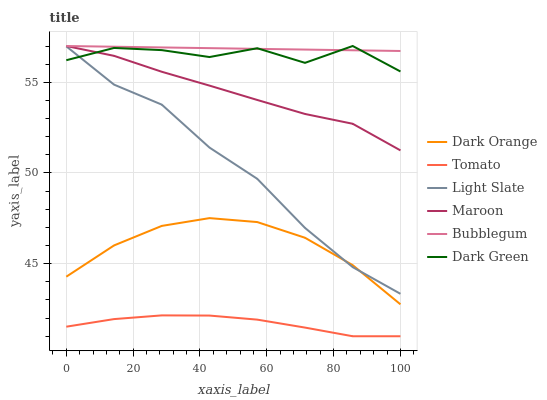Does Tomato have the minimum area under the curve?
Answer yes or no. Yes. Does Bubblegum have the maximum area under the curve?
Answer yes or no. Yes. Does Dark Orange have the minimum area under the curve?
Answer yes or no. No. Does Dark Orange have the maximum area under the curve?
Answer yes or no. No. Is Bubblegum the smoothest?
Answer yes or no. Yes. Is Dark Green the roughest?
Answer yes or no. Yes. Is Dark Orange the smoothest?
Answer yes or no. No. Is Dark Orange the roughest?
Answer yes or no. No. Does Tomato have the lowest value?
Answer yes or no. Yes. Does Dark Orange have the lowest value?
Answer yes or no. No. Does Dark Green have the highest value?
Answer yes or no. Yes. Does Dark Orange have the highest value?
Answer yes or no. No. Is Dark Orange less than Maroon?
Answer yes or no. Yes. Is Bubblegum greater than Tomato?
Answer yes or no. Yes. Does Bubblegum intersect Maroon?
Answer yes or no. Yes. Is Bubblegum less than Maroon?
Answer yes or no. No. Is Bubblegum greater than Maroon?
Answer yes or no. No. Does Dark Orange intersect Maroon?
Answer yes or no. No. 